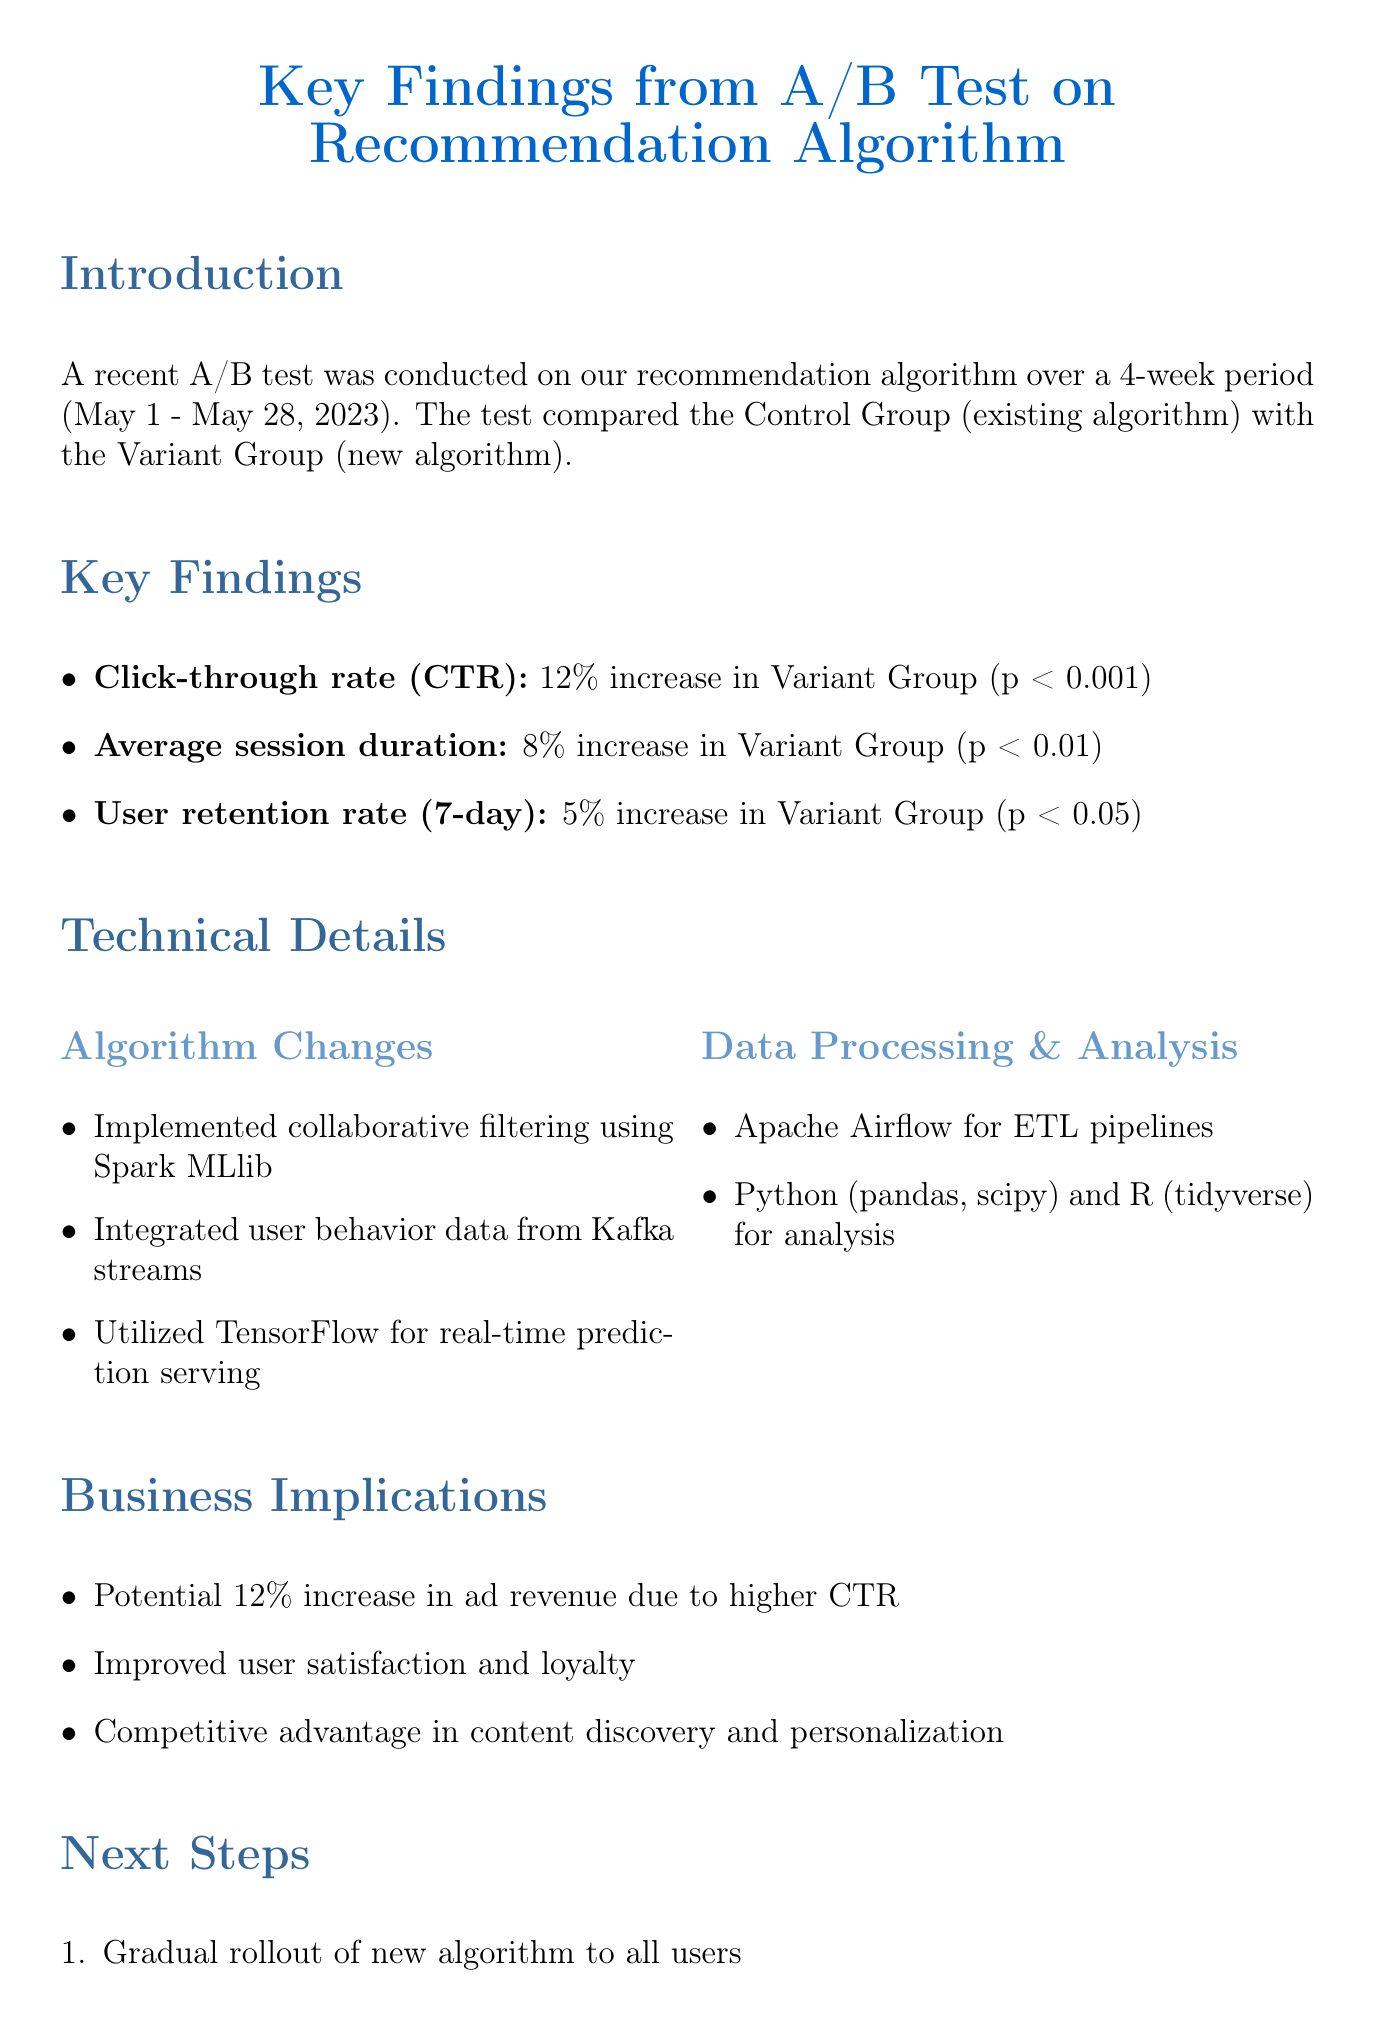What was the test period for the A/B test? The test period for the A/B test is specified in the introduction section of the document as four weeks from May 1 to May 28, 2023.
Answer: 4 weeks (May 1 - May 28, 2023) What metric showed a 12% increase in the Variant Group? The key findings section indicates that the Click-through rate (CTR) exhibited a 12% increase in the Variant Group.
Answer: Click-through rate (CTR) What was the p-value for the average session duration result? The statistical significance of the average session duration, which shows an 8% increase, is indicated with a p-value of less than 0.01 in the key findings.
Answer: p-value < 0.01 What is one of the algorithm changes implemented? The technical details section lists several algorithm changes; one of them being implementing collaborative filtering using Spark MLlib.
Answer: Implemented collaborative filtering using Spark MLlib What is mentioned as a potential business implication of the findings? The business implications section highlights several outcomes; one potential outcome is a 12% increase in ad revenue due to higher CTR.
Answer: Potential 12% increase in ad revenue due to higher CTR How many team members are listed in the appendix? The appendix of the document mentions four team members involved in the project.
Answer: 4 team members What type of visualization is used to compare CTR? The document specifies that a bar chart is used to compare CTR between the Control and Variant Groups.
Answer: Bar chart What are the next steps after the A/B test? The next steps include a gradual rollout of the new algorithm to all users, among other actions listed.
Answer: Gradual rollout of new algorithm to all users 